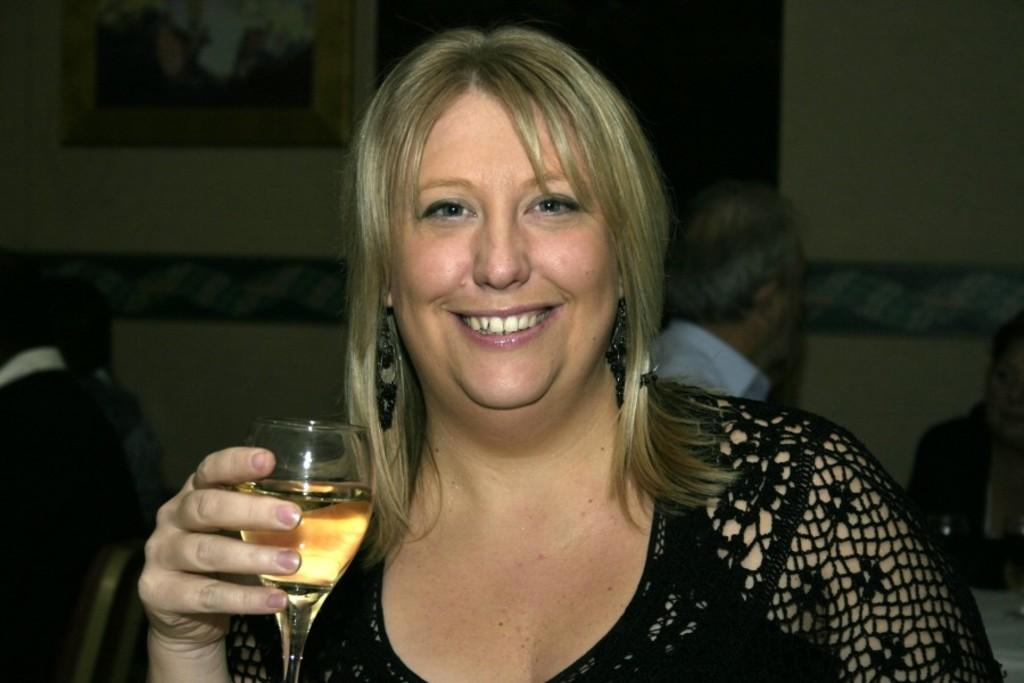Who is present in the image? There is a woman in the image. What is the woman holding in the image? The woman is holding a wine glass. What is the woman's facial expression in the image? The woman is smiling. What can be seen in the background of the image? There is a wall and people sitting on chairs in the background of the image. What type of shoes is the woman wearing in the image? There is no information about the woman's shoes in the image, so we cannot determine what type she is wearing. 